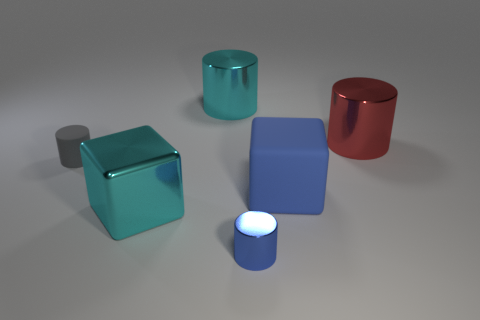Are any small blue metal things visible?
Your response must be concise. Yes. What shape is the big red thing that is the same material as the small blue thing?
Give a very brief answer. Cylinder. There is a cylinder in front of the cyan metal block; what material is it?
Make the answer very short. Metal. Does the large cube on the right side of the big metallic cube have the same color as the rubber cylinder?
Offer a very short reply. No. What size is the cyan metallic block that is in front of the matte thing right of the tiny rubber cylinder?
Your answer should be very brief. Large. Are there more matte cubes behind the small gray matte cylinder than small brown blocks?
Provide a succinct answer. No. There is a cylinder in front of the cyan cube; does it have the same size as the tiny rubber cylinder?
Make the answer very short. Yes. There is a metal cylinder that is both behind the large blue rubber block and to the left of the large rubber block; what is its color?
Your answer should be compact. Cyan. What shape is the red metallic object that is the same size as the cyan cylinder?
Ensure brevity in your answer.  Cylinder. Is there a big sphere that has the same color as the small matte cylinder?
Give a very brief answer. No. 